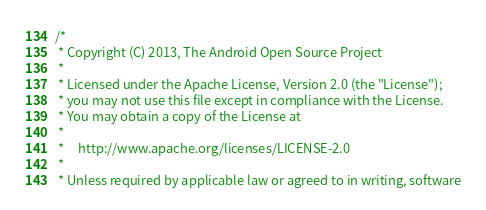<code> <loc_0><loc_0><loc_500><loc_500><_C++_>/*
 * Copyright (C) 2013, The Android Open Source Project
 *
 * Licensed under the Apache License, Version 2.0 (the "License");
 * you may not use this file except in compliance with the License.
 * You may obtain a copy of the License at
 *
 *     http://www.apache.org/licenses/LICENSE-2.0
 *
 * Unless required by applicable law or agreed to in writing, software</code> 